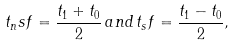<formula> <loc_0><loc_0><loc_500><loc_500>t _ { n } s f = \frac { t _ { 1 } + t _ { 0 } } { 2 } \, a n d \, t _ { s } f = \frac { t _ { 1 } - t _ { 0 } } { 2 } ,</formula> 